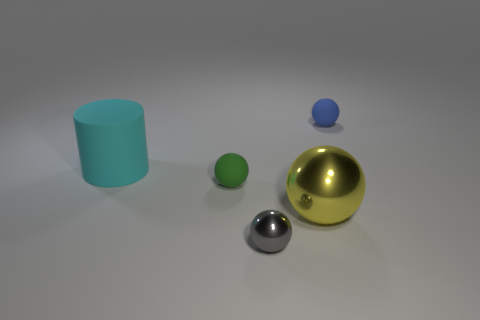Is there any other thing that has the same shape as the big cyan rubber thing?
Offer a very short reply. No. How many tiny matte things are to the right of the blue thing that is on the right side of the gray object?
Your response must be concise. 0. What color is the sphere that is made of the same material as the gray object?
Your answer should be very brief. Yellow. Are there any metallic things of the same size as the cyan cylinder?
Provide a succinct answer. Yes. There is a metallic thing that is the same size as the green rubber object; what shape is it?
Ensure brevity in your answer.  Sphere. Is there a small gray thing of the same shape as the blue object?
Your answer should be compact. Yes. Are the small blue ball and the green object that is in front of the cyan matte cylinder made of the same material?
Offer a very short reply. Yes. What number of other objects are there of the same material as the large ball?
Offer a terse response. 1. Is the number of rubber cylinders that are left of the tiny blue matte thing greater than the number of shiny cubes?
Offer a terse response. Yes. There is a rubber sphere in front of the blue sphere behind the tiny metallic thing; what number of things are in front of it?
Offer a very short reply. 2. 